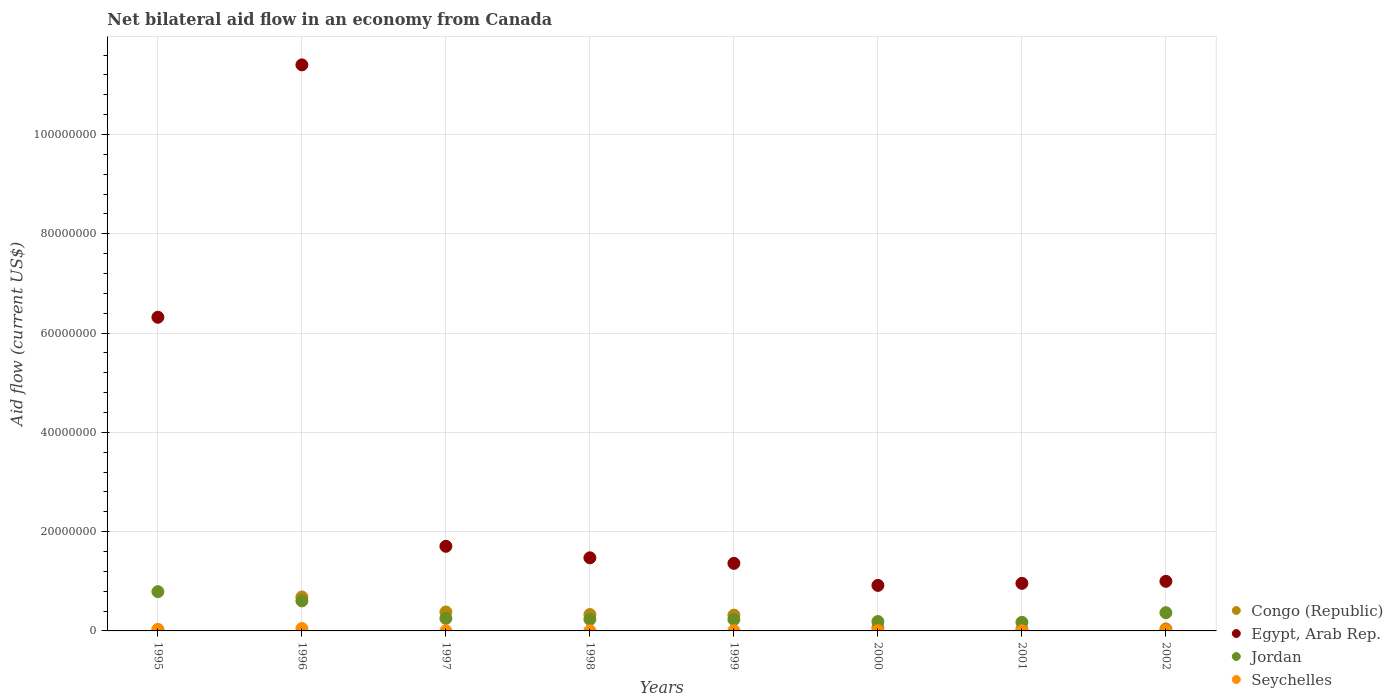How many different coloured dotlines are there?
Your answer should be compact. 4. What is the net bilateral aid flow in Jordan in 1996?
Offer a terse response. 6.05e+06. Across all years, what is the minimum net bilateral aid flow in Jordan?
Your response must be concise. 1.73e+06. In which year was the net bilateral aid flow in Egypt, Arab Rep. minimum?
Provide a short and direct response. 2000. What is the total net bilateral aid flow in Congo (Republic) in the graph?
Your answer should be very brief. 1.88e+07. What is the difference between the net bilateral aid flow in Jordan in 1995 and that in 1996?
Your answer should be very brief. 1.86e+06. What is the difference between the net bilateral aid flow in Jordan in 1995 and the net bilateral aid flow in Congo (Republic) in 2001?
Your answer should be compact. 7.57e+06. What is the average net bilateral aid flow in Congo (Republic) per year?
Your answer should be compact. 2.34e+06. In the year 1996, what is the difference between the net bilateral aid flow in Congo (Republic) and net bilateral aid flow in Egypt, Arab Rep.?
Ensure brevity in your answer.  -1.07e+08. What is the ratio of the net bilateral aid flow in Jordan in 1998 to that in 2002?
Your answer should be very brief. 0.63. Is the net bilateral aid flow in Egypt, Arab Rep. in 1997 less than that in 1998?
Give a very brief answer. No. Is the difference between the net bilateral aid flow in Congo (Republic) in 1996 and 2000 greater than the difference between the net bilateral aid flow in Egypt, Arab Rep. in 1996 and 2000?
Offer a very short reply. No. What is the difference between the highest and the second highest net bilateral aid flow in Jordan?
Your response must be concise. 1.86e+06. What is the difference between the highest and the lowest net bilateral aid flow in Jordan?
Ensure brevity in your answer.  6.18e+06. In how many years, is the net bilateral aid flow in Seychelles greater than the average net bilateral aid flow in Seychelles taken over all years?
Offer a very short reply. 2. Is the sum of the net bilateral aid flow in Congo (Republic) in 1999 and 2002 greater than the maximum net bilateral aid flow in Egypt, Arab Rep. across all years?
Provide a succinct answer. No. Is it the case that in every year, the sum of the net bilateral aid flow in Egypt, Arab Rep. and net bilateral aid flow in Congo (Republic)  is greater than the sum of net bilateral aid flow in Jordan and net bilateral aid flow in Seychelles?
Ensure brevity in your answer.  No. Is it the case that in every year, the sum of the net bilateral aid flow in Egypt, Arab Rep. and net bilateral aid flow in Jordan  is greater than the net bilateral aid flow in Seychelles?
Keep it short and to the point. Yes. Is the net bilateral aid flow in Seychelles strictly greater than the net bilateral aid flow in Congo (Republic) over the years?
Your answer should be very brief. No. How many dotlines are there?
Give a very brief answer. 4. How many years are there in the graph?
Ensure brevity in your answer.  8. What is the difference between two consecutive major ticks on the Y-axis?
Ensure brevity in your answer.  2.00e+07. Does the graph contain any zero values?
Offer a very short reply. No. What is the title of the graph?
Your response must be concise. Net bilateral aid flow in an economy from Canada. Does "Ghana" appear as one of the legend labels in the graph?
Ensure brevity in your answer.  No. What is the label or title of the X-axis?
Make the answer very short. Years. What is the Aid flow (current US$) of Egypt, Arab Rep. in 1995?
Your response must be concise. 6.32e+07. What is the Aid flow (current US$) in Jordan in 1995?
Provide a succinct answer. 7.91e+06. What is the Aid flow (current US$) in Congo (Republic) in 1996?
Your response must be concise. 6.84e+06. What is the Aid flow (current US$) of Egypt, Arab Rep. in 1996?
Make the answer very short. 1.14e+08. What is the Aid flow (current US$) of Jordan in 1996?
Your answer should be very brief. 6.05e+06. What is the Aid flow (current US$) in Congo (Republic) in 1997?
Provide a succinct answer. 3.82e+06. What is the Aid flow (current US$) of Egypt, Arab Rep. in 1997?
Provide a short and direct response. 1.70e+07. What is the Aid flow (current US$) of Jordan in 1997?
Give a very brief answer. 2.52e+06. What is the Aid flow (current US$) in Seychelles in 1997?
Your response must be concise. 2.00e+04. What is the Aid flow (current US$) in Congo (Republic) in 1998?
Offer a very short reply. 3.30e+06. What is the Aid flow (current US$) of Egypt, Arab Rep. in 1998?
Offer a very short reply. 1.47e+07. What is the Aid flow (current US$) of Jordan in 1998?
Offer a very short reply. 2.33e+06. What is the Aid flow (current US$) of Seychelles in 1998?
Your answer should be compact. 3.00e+04. What is the Aid flow (current US$) in Congo (Republic) in 1999?
Provide a succinct answer. 3.18e+06. What is the Aid flow (current US$) of Egypt, Arab Rep. in 1999?
Provide a short and direct response. 1.36e+07. What is the Aid flow (current US$) in Jordan in 1999?
Your answer should be very brief. 2.31e+06. What is the Aid flow (current US$) in Congo (Republic) in 2000?
Make the answer very short. 6.70e+05. What is the Aid flow (current US$) in Egypt, Arab Rep. in 2000?
Give a very brief answer. 9.17e+06. What is the Aid flow (current US$) of Jordan in 2000?
Provide a short and direct response. 1.89e+06. What is the Aid flow (current US$) in Seychelles in 2000?
Offer a terse response. 5.00e+04. What is the Aid flow (current US$) of Congo (Republic) in 2001?
Offer a terse response. 3.40e+05. What is the Aid flow (current US$) of Egypt, Arab Rep. in 2001?
Provide a succinct answer. 9.58e+06. What is the Aid flow (current US$) of Jordan in 2001?
Your response must be concise. 1.73e+06. What is the Aid flow (current US$) in Seychelles in 2001?
Your answer should be compact. 2.00e+04. What is the Aid flow (current US$) of Congo (Republic) in 2002?
Provide a short and direct response. 4.00e+05. What is the Aid flow (current US$) of Egypt, Arab Rep. in 2002?
Offer a terse response. 9.99e+06. What is the Aid flow (current US$) in Jordan in 2002?
Your answer should be very brief. 3.67e+06. Across all years, what is the maximum Aid flow (current US$) in Congo (Republic)?
Ensure brevity in your answer.  6.84e+06. Across all years, what is the maximum Aid flow (current US$) of Egypt, Arab Rep.?
Your response must be concise. 1.14e+08. Across all years, what is the maximum Aid flow (current US$) in Jordan?
Provide a succinct answer. 7.91e+06. Across all years, what is the maximum Aid flow (current US$) in Seychelles?
Keep it short and to the point. 4.80e+05. Across all years, what is the minimum Aid flow (current US$) of Egypt, Arab Rep.?
Offer a terse response. 9.17e+06. Across all years, what is the minimum Aid flow (current US$) in Jordan?
Provide a succinct answer. 1.73e+06. Across all years, what is the minimum Aid flow (current US$) in Seychelles?
Provide a succinct answer. 2.00e+04. What is the total Aid flow (current US$) in Congo (Republic) in the graph?
Provide a short and direct response. 1.88e+07. What is the total Aid flow (current US$) of Egypt, Arab Rep. in the graph?
Your answer should be compact. 2.51e+08. What is the total Aid flow (current US$) in Jordan in the graph?
Make the answer very short. 2.84e+07. What is the total Aid flow (current US$) in Seychelles in the graph?
Provide a succinct answer. 1.02e+06. What is the difference between the Aid flow (current US$) in Congo (Republic) in 1995 and that in 1996?
Make the answer very short. -6.63e+06. What is the difference between the Aid flow (current US$) of Egypt, Arab Rep. in 1995 and that in 1996?
Ensure brevity in your answer.  -5.08e+07. What is the difference between the Aid flow (current US$) in Jordan in 1995 and that in 1996?
Your response must be concise. 1.86e+06. What is the difference between the Aid flow (current US$) in Congo (Republic) in 1995 and that in 1997?
Ensure brevity in your answer.  -3.61e+06. What is the difference between the Aid flow (current US$) in Egypt, Arab Rep. in 1995 and that in 1997?
Offer a very short reply. 4.61e+07. What is the difference between the Aid flow (current US$) in Jordan in 1995 and that in 1997?
Your answer should be very brief. 5.39e+06. What is the difference between the Aid flow (current US$) of Congo (Republic) in 1995 and that in 1998?
Your answer should be very brief. -3.09e+06. What is the difference between the Aid flow (current US$) in Egypt, Arab Rep. in 1995 and that in 1998?
Keep it short and to the point. 4.85e+07. What is the difference between the Aid flow (current US$) in Jordan in 1995 and that in 1998?
Keep it short and to the point. 5.58e+06. What is the difference between the Aid flow (current US$) of Congo (Republic) in 1995 and that in 1999?
Provide a succinct answer. -2.97e+06. What is the difference between the Aid flow (current US$) in Egypt, Arab Rep. in 1995 and that in 1999?
Ensure brevity in your answer.  4.96e+07. What is the difference between the Aid flow (current US$) of Jordan in 1995 and that in 1999?
Offer a terse response. 5.60e+06. What is the difference between the Aid flow (current US$) in Congo (Republic) in 1995 and that in 2000?
Your response must be concise. -4.60e+05. What is the difference between the Aid flow (current US$) of Egypt, Arab Rep. in 1995 and that in 2000?
Your answer should be very brief. 5.40e+07. What is the difference between the Aid flow (current US$) of Jordan in 1995 and that in 2000?
Your answer should be compact. 6.02e+06. What is the difference between the Aid flow (current US$) of Egypt, Arab Rep. in 1995 and that in 2001?
Keep it short and to the point. 5.36e+07. What is the difference between the Aid flow (current US$) in Jordan in 1995 and that in 2001?
Your answer should be compact. 6.18e+06. What is the difference between the Aid flow (current US$) of Seychelles in 1995 and that in 2001?
Offer a very short reply. 2.80e+05. What is the difference between the Aid flow (current US$) in Congo (Republic) in 1995 and that in 2002?
Offer a very short reply. -1.90e+05. What is the difference between the Aid flow (current US$) in Egypt, Arab Rep. in 1995 and that in 2002?
Keep it short and to the point. 5.32e+07. What is the difference between the Aid flow (current US$) in Jordan in 1995 and that in 2002?
Give a very brief answer. 4.24e+06. What is the difference between the Aid flow (current US$) in Congo (Republic) in 1996 and that in 1997?
Ensure brevity in your answer.  3.02e+06. What is the difference between the Aid flow (current US$) in Egypt, Arab Rep. in 1996 and that in 1997?
Your answer should be very brief. 9.70e+07. What is the difference between the Aid flow (current US$) of Jordan in 1996 and that in 1997?
Your response must be concise. 3.53e+06. What is the difference between the Aid flow (current US$) of Congo (Republic) in 1996 and that in 1998?
Offer a very short reply. 3.54e+06. What is the difference between the Aid flow (current US$) in Egypt, Arab Rep. in 1996 and that in 1998?
Keep it short and to the point. 9.93e+07. What is the difference between the Aid flow (current US$) of Jordan in 1996 and that in 1998?
Make the answer very short. 3.72e+06. What is the difference between the Aid flow (current US$) of Seychelles in 1996 and that in 1998?
Make the answer very short. 4.50e+05. What is the difference between the Aid flow (current US$) in Congo (Republic) in 1996 and that in 1999?
Provide a succinct answer. 3.66e+06. What is the difference between the Aid flow (current US$) in Egypt, Arab Rep. in 1996 and that in 1999?
Provide a short and direct response. 1.00e+08. What is the difference between the Aid flow (current US$) of Jordan in 1996 and that in 1999?
Give a very brief answer. 3.74e+06. What is the difference between the Aid flow (current US$) in Congo (Republic) in 1996 and that in 2000?
Offer a very short reply. 6.17e+06. What is the difference between the Aid flow (current US$) in Egypt, Arab Rep. in 1996 and that in 2000?
Provide a short and direct response. 1.05e+08. What is the difference between the Aid flow (current US$) of Jordan in 1996 and that in 2000?
Ensure brevity in your answer.  4.16e+06. What is the difference between the Aid flow (current US$) of Congo (Republic) in 1996 and that in 2001?
Your response must be concise. 6.50e+06. What is the difference between the Aid flow (current US$) of Egypt, Arab Rep. in 1996 and that in 2001?
Your answer should be compact. 1.04e+08. What is the difference between the Aid flow (current US$) in Jordan in 1996 and that in 2001?
Offer a very short reply. 4.32e+06. What is the difference between the Aid flow (current US$) in Seychelles in 1996 and that in 2001?
Provide a succinct answer. 4.60e+05. What is the difference between the Aid flow (current US$) of Congo (Republic) in 1996 and that in 2002?
Keep it short and to the point. 6.44e+06. What is the difference between the Aid flow (current US$) of Egypt, Arab Rep. in 1996 and that in 2002?
Make the answer very short. 1.04e+08. What is the difference between the Aid flow (current US$) in Jordan in 1996 and that in 2002?
Offer a very short reply. 2.38e+06. What is the difference between the Aid flow (current US$) of Seychelles in 1996 and that in 2002?
Your response must be concise. 4.10e+05. What is the difference between the Aid flow (current US$) of Congo (Republic) in 1997 and that in 1998?
Your answer should be very brief. 5.20e+05. What is the difference between the Aid flow (current US$) of Egypt, Arab Rep. in 1997 and that in 1998?
Make the answer very short. 2.32e+06. What is the difference between the Aid flow (current US$) in Seychelles in 1997 and that in 1998?
Ensure brevity in your answer.  -10000. What is the difference between the Aid flow (current US$) in Congo (Republic) in 1997 and that in 1999?
Offer a terse response. 6.40e+05. What is the difference between the Aid flow (current US$) in Egypt, Arab Rep. in 1997 and that in 1999?
Your response must be concise. 3.44e+06. What is the difference between the Aid flow (current US$) in Seychelles in 1997 and that in 1999?
Make the answer very short. -3.00e+04. What is the difference between the Aid flow (current US$) of Congo (Republic) in 1997 and that in 2000?
Ensure brevity in your answer.  3.15e+06. What is the difference between the Aid flow (current US$) of Egypt, Arab Rep. in 1997 and that in 2000?
Offer a very short reply. 7.88e+06. What is the difference between the Aid flow (current US$) in Jordan in 1997 and that in 2000?
Offer a terse response. 6.30e+05. What is the difference between the Aid flow (current US$) in Seychelles in 1997 and that in 2000?
Offer a very short reply. -3.00e+04. What is the difference between the Aid flow (current US$) of Congo (Republic) in 1997 and that in 2001?
Provide a succinct answer. 3.48e+06. What is the difference between the Aid flow (current US$) in Egypt, Arab Rep. in 1997 and that in 2001?
Offer a terse response. 7.47e+06. What is the difference between the Aid flow (current US$) in Jordan in 1997 and that in 2001?
Make the answer very short. 7.90e+05. What is the difference between the Aid flow (current US$) in Seychelles in 1997 and that in 2001?
Your answer should be very brief. 0. What is the difference between the Aid flow (current US$) of Congo (Republic) in 1997 and that in 2002?
Your answer should be compact. 3.42e+06. What is the difference between the Aid flow (current US$) of Egypt, Arab Rep. in 1997 and that in 2002?
Your response must be concise. 7.06e+06. What is the difference between the Aid flow (current US$) in Jordan in 1997 and that in 2002?
Offer a terse response. -1.15e+06. What is the difference between the Aid flow (current US$) in Seychelles in 1997 and that in 2002?
Ensure brevity in your answer.  -5.00e+04. What is the difference between the Aid flow (current US$) in Egypt, Arab Rep. in 1998 and that in 1999?
Give a very brief answer. 1.12e+06. What is the difference between the Aid flow (current US$) in Seychelles in 1998 and that in 1999?
Offer a very short reply. -2.00e+04. What is the difference between the Aid flow (current US$) of Congo (Republic) in 1998 and that in 2000?
Your answer should be very brief. 2.63e+06. What is the difference between the Aid flow (current US$) in Egypt, Arab Rep. in 1998 and that in 2000?
Your answer should be compact. 5.56e+06. What is the difference between the Aid flow (current US$) in Jordan in 1998 and that in 2000?
Your answer should be compact. 4.40e+05. What is the difference between the Aid flow (current US$) in Seychelles in 1998 and that in 2000?
Keep it short and to the point. -2.00e+04. What is the difference between the Aid flow (current US$) in Congo (Republic) in 1998 and that in 2001?
Give a very brief answer. 2.96e+06. What is the difference between the Aid flow (current US$) of Egypt, Arab Rep. in 1998 and that in 2001?
Offer a terse response. 5.15e+06. What is the difference between the Aid flow (current US$) in Jordan in 1998 and that in 2001?
Your answer should be compact. 6.00e+05. What is the difference between the Aid flow (current US$) of Congo (Republic) in 1998 and that in 2002?
Give a very brief answer. 2.90e+06. What is the difference between the Aid flow (current US$) of Egypt, Arab Rep. in 1998 and that in 2002?
Keep it short and to the point. 4.74e+06. What is the difference between the Aid flow (current US$) of Jordan in 1998 and that in 2002?
Ensure brevity in your answer.  -1.34e+06. What is the difference between the Aid flow (current US$) in Congo (Republic) in 1999 and that in 2000?
Offer a very short reply. 2.51e+06. What is the difference between the Aid flow (current US$) in Egypt, Arab Rep. in 1999 and that in 2000?
Provide a short and direct response. 4.44e+06. What is the difference between the Aid flow (current US$) of Jordan in 1999 and that in 2000?
Your answer should be very brief. 4.20e+05. What is the difference between the Aid flow (current US$) in Congo (Republic) in 1999 and that in 2001?
Make the answer very short. 2.84e+06. What is the difference between the Aid flow (current US$) of Egypt, Arab Rep. in 1999 and that in 2001?
Your answer should be compact. 4.03e+06. What is the difference between the Aid flow (current US$) of Jordan in 1999 and that in 2001?
Offer a very short reply. 5.80e+05. What is the difference between the Aid flow (current US$) of Congo (Republic) in 1999 and that in 2002?
Offer a terse response. 2.78e+06. What is the difference between the Aid flow (current US$) in Egypt, Arab Rep. in 1999 and that in 2002?
Ensure brevity in your answer.  3.62e+06. What is the difference between the Aid flow (current US$) of Jordan in 1999 and that in 2002?
Keep it short and to the point. -1.36e+06. What is the difference between the Aid flow (current US$) of Egypt, Arab Rep. in 2000 and that in 2001?
Ensure brevity in your answer.  -4.10e+05. What is the difference between the Aid flow (current US$) of Jordan in 2000 and that in 2001?
Offer a very short reply. 1.60e+05. What is the difference between the Aid flow (current US$) of Congo (Republic) in 2000 and that in 2002?
Your response must be concise. 2.70e+05. What is the difference between the Aid flow (current US$) in Egypt, Arab Rep. in 2000 and that in 2002?
Give a very brief answer. -8.20e+05. What is the difference between the Aid flow (current US$) in Jordan in 2000 and that in 2002?
Ensure brevity in your answer.  -1.78e+06. What is the difference between the Aid flow (current US$) of Seychelles in 2000 and that in 2002?
Offer a very short reply. -2.00e+04. What is the difference between the Aid flow (current US$) of Congo (Republic) in 2001 and that in 2002?
Give a very brief answer. -6.00e+04. What is the difference between the Aid flow (current US$) in Egypt, Arab Rep. in 2001 and that in 2002?
Your answer should be very brief. -4.10e+05. What is the difference between the Aid flow (current US$) of Jordan in 2001 and that in 2002?
Keep it short and to the point. -1.94e+06. What is the difference between the Aid flow (current US$) in Seychelles in 2001 and that in 2002?
Give a very brief answer. -5.00e+04. What is the difference between the Aid flow (current US$) in Congo (Republic) in 1995 and the Aid flow (current US$) in Egypt, Arab Rep. in 1996?
Provide a succinct answer. -1.14e+08. What is the difference between the Aid flow (current US$) of Congo (Republic) in 1995 and the Aid flow (current US$) of Jordan in 1996?
Your response must be concise. -5.84e+06. What is the difference between the Aid flow (current US$) in Congo (Republic) in 1995 and the Aid flow (current US$) in Seychelles in 1996?
Provide a succinct answer. -2.70e+05. What is the difference between the Aid flow (current US$) of Egypt, Arab Rep. in 1995 and the Aid flow (current US$) of Jordan in 1996?
Keep it short and to the point. 5.71e+07. What is the difference between the Aid flow (current US$) of Egypt, Arab Rep. in 1995 and the Aid flow (current US$) of Seychelles in 1996?
Provide a succinct answer. 6.27e+07. What is the difference between the Aid flow (current US$) of Jordan in 1995 and the Aid flow (current US$) of Seychelles in 1996?
Your answer should be compact. 7.43e+06. What is the difference between the Aid flow (current US$) of Congo (Republic) in 1995 and the Aid flow (current US$) of Egypt, Arab Rep. in 1997?
Give a very brief answer. -1.68e+07. What is the difference between the Aid flow (current US$) of Congo (Republic) in 1995 and the Aid flow (current US$) of Jordan in 1997?
Offer a terse response. -2.31e+06. What is the difference between the Aid flow (current US$) of Egypt, Arab Rep. in 1995 and the Aid flow (current US$) of Jordan in 1997?
Give a very brief answer. 6.07e+07. What is the difference between the Aid flow (current US$) of Egypt, Arab Rep. in 1995 and the Aid flow (current US$) of Seychelles in 1997?
Your response must be concise. 6.32e+07. What is the difference between the Aid flow (current US$) of Jordan in 1995 and the Aid flow (current US$) of Seychelles in 1997?
Provide a succinct answer. 7.89e+06. What is the difference between the Aid flow (current US$) of Congo (Republic) in 1995 and the Aid flow (current US$) of Egypt, Arab Rep. in 1998?
Offer a terse response. -1.45e+07. What is the difference between the Aid flow (current US$) in Congo (Republic) in 1995 and the Aid flow (current US$) in Jordan in 1998?
Ensure brevity in your answer.  -2.12e+06. What is the difference between the Aid flow (current US$) of Congo (Republic) in 1995 and the Aid flow (current US$) of Seychelles in 1998?
Make the answer very short. 1.80e+05. What is the difference between the Aid flow (current US$) in Egypt, Arab Rep. in 1995 and the Aid flow (current US$) in Jordan in 1998?
Offer a terse response. 6.09e+07. What is the difference between the Aid flow (current US$) in Egypt, Arab Rep. in 1995 and the Aid flow (current US$) in Seychelles in 1998?
Provide a succinct answer. 6.32e+07. What is the difference between the Aid flow (current US$) in Jordan in 1995 and the Aid flow (current US$) in Seychelles in 1998?
Ensure brevity in your answer.  7.88e+06. What is the difference between the Aid flow (current US$) in Congo (Republic) in 1995 and the Aid flow (current US$) in Egypt, Arab Rep. in 1999?
Provide a short and direct response. -1.34e+07. What is the difference between the Aid flow (current US$) in Congo (Republic) in 1995 and the Aid flow (current US$) in Jordan in 1999?
Provide a succinct answer. -2.10e+06. What is the difference between the Aid flow (current US$) in Egypt, Arab Rep. in 1995 and the Aid flow (current US$) in Jordan in 1999?
Give a very brief answer. 6.09e+07. What is the difference between the Aid flow (current US$) of Egypt, Arab Rep. in 1995 and the Aid flow (current US$) of Seychelles in 1999?
Ensure brevity in your answer.  6.31e+07. What is the difference between the Aid flow (current US$) of Jordan in 1995 and the Aid flow (current US$) of Seychelles in 1999?
Provide a succinct answer. 7.86e+06. What is the difference between the Aid flow (current US$) in Congo (Republic) in 1995 and the Aid flow (current US$) in Egypt, Arab Rep. in 2000?
Provide a short and direct response. -8.96e+06. What is the difference between the Aid flow (current US$) in Congo (Republic) in 1995 and the Aid flow (current US$) in Jordan in 2000?
Offer a terse response. -1.68e+06. What is the difference between the Aid flow (current US$) of Egypt, Arab Rep. in 1995 and the Aid flow (current US$) of Jordan in 2000?
Provide a succinct answer. 6.13e+07. What is the difference between the Aid flow (current US$) of Egypt, Arab Rep. in 1995 and the Aid flow (current US$) of Seychelles in 2000?
Your response must be concise. 6.31e+07. What is the difference between the Aid flow (current US$) of Jordan in 1995 and the Aid flow (current US$) of Seychelles in 2000?
Offer a very short reply. 7.86e+06. What is the difference between the Aid flow (current US$) in Congo (Republic) in 1995 and the Aid flow (current US$) in Egypt, Arab Rep. in 2001?
Your answer should be very brief. -9.37e+06. What is the difference between the Aid flow (current US$) in Congo (Republic) in 1995 and the Aid flow (current US$) in Jordan in 2001?
Offer a terse response. -1.52e+06. What is the difference between the Aid flow (current US$) in Egypt, Arab Rep. in 1995 and the Aid flow (current US$) in Jordan in 2001?
Provide a succinct answer. 6.15e+07. What is the difference between the Aid flow (current US$) in Egypt, Arab Rep. in 1995 and the Aid flow (current US$) in Seychelles in 2001?
Your answer should be compact. 6.32e+07. What is the difference between the Aid flow (current US$) of Jordan in 1995 and the Aid flow (current US$) of Seychelles in 2001?
Offer a very short reply. 7.89e+06. What is the difference between the Aid flow (current US$) of Congo (Republic) in 1995 and the Aid flow (current US$) of Egypt, Arab Rep. in 2002?
Your answer should be very brief. -9.78e+06. What is the difference between the Aid flow (current US$) of Congo (Republic) in 1995 and the Aid flow (current US$) of Jordan in 2002?
Provide a succinct answer. -3.46e+06. What is the difference between the Aid flow (current US$) of Egypt, Arab Rep. in 1995 and the Aid flow (current US$) of Jordan in 2002?
Ensure brevity in your answer.  5.95e+07. What is the difference between the Aid flow (current US$) in Egypt, Arab Rep. in 1995 and the Aid flow (current US$) in Seychelles in 2002?
Offer a very short reply. 6.31e+07. What is the difference between the Aid flow (current US$) of Jordan in 1995 and the Aid flow (current US$) of Seychelles in 2002?
Give a very brief answer. 7.84e+06. What is the difference between the Aid flow (current US$) in Congo (Republic) in 1996 and the Aid flow (current US$) in Egypt, Arab Rep. in 1997?
Provide a short and direct response. -1.02e+07. What is the difference between the Aid flow (current US$) in Congo (Republic) in 1996 and the Aid flow (current US$) in Jordan in 1997?
Provide a short and direct response. 4.32e+06. What is the difference between the Aid flow (current US$) in Congo (Republic) in 1996 and the Aid flow (current US$) in Seychelles in 1997?
Keep it short and to the point. 6.82e+06. What is the difference between the Aid flow (current US$) in Egypt, Arab Rep. in 1996 and the Aid flow (current US$) in Jordan in 1997?
Give a very brief answer. 1.12e+08. What is the difference between the Aid flow (current US$) of Egypt, Arab Rep. in 1996 and the Aid flow (current US$) of Seychelles in 1997?
Ensure brevity in your answer.  1.14e+08. What is the difference between the Aid flow (current US$) in Jordan in 1996 and the Aid flow (current US$) in Seychelles in 1997?
Give a very brief answer. 6.03e+06. What is the difference between the Aid flow (current US$) of Congo (Republic) in 1996 and the Aid flow (current US$) of Egypt, Arab Rep. in 1998?
Your response must be concise. -7.89e+06. What is the difference between the Aid flow (current US$) in Congo (Republic) in 1996 and the Aid flow (current US$) in Jordan in 1998?
Offer a terse response. 4.51e+06. What is the difference between the Aid flow (current US$) in Congo (Republic) in 1996 and the Aid flow (current US$) in Seychelles in 1998?
Your answer should be very brief. 6.81e+06. What is the difference between the Aid flow (current US$) of Egypt, Arab Rep. in 1996 and the Aid flow (current US$) of Jordan in 1998?
Your answer should be compact. 1.12e+08. What is the difference between the Aid flow (current US$) in Egypt, Arab Rep. in 1996 and the Aid flow (current US$) in Seychelles in 1998?
Offer a terse response. 1.14e+08. What is the difference between the Aid flow (current US$) of Jordan in 1996 and the Aid flow (current US$) of Seychelles in 1998?
Your answer should be very brief. 6.02e+06. What is the difference between the Aid flow (current US$) in Congo (Republic) in 1996 and the Aid flow (current US$) in Egypt, Arab Rep. in 1999?
Make the answer very short. -6.77e+06. What is the difference between the Aid flow (current US$) of Congo (Republic) in 1996 and the Aid flow (current US$) of Jordan in 1999?
Keep it short and to the point. 4.53e+06. What is the difference between the Aid flow (current US$) in Congo (Republic) in 1996 and the Aid flow (current US$) in Seychelles in 1999?
Ensure brevity in your answer.  6.79e+06. What is the difference between the Aid flow (current US$) in Egypt, Arab Rep. in 1996 and the Aid flow (current US$) in Jordan in 1999?
Make the answer very short. 1.12e+08. What is the difference between the Aid flow (current US$) of Egypt, Arab Rep. in 1996 and the Aid flow (current US$) of Seychelles in 1999?
Your answer should be compact. 1.14e+08. What is the difference between the Aid flow (current US$) of Congo (Republic) in 1996 and the Aid flow (current US$) of Egypt, Arab Rep. in 2000?
Ensure brevity in your answer.  -2.33e+06. What is the difference between the Aid flow (current US$) of Congo (Republic) in 1996 and the Aid flow (current US$) of Jordan in 2000?
Your answer should be very brief. 4.95e+06. What is the difference between the Aid flow (current US$) of Congo (Republic) in 1996 and the Aid flow (current US$) of Seychelles in 2000?
Your answer should be very brief. 6.79e+06. What is the difference between the Aid flow (current US$) of Egypt, Arab Rep. in 1996 and the Aid flow (current US$) of Jordan in 2000?
Your answer should be very brief. 1.12e+08. What is the difference between the Aid flow (current US$) of Egypt, Arab Rep. in 1996 and the Aid flow (current US$) of Seychelles in 2000?
Provide a succinct answer. 1.14e+08. What is the difference between the Aid flow (current US$) in Congo (Republic) in 1996 and the Aid flow (current US$) in Egypt, Arab Rep. in 2001?
Keep it short and to the point. -2.74e+06. What is the difference between the Aid flow (current US$) of Congo (Republic) in 1996 and the Aid flow (current US$) of Jordan in 2001?
Offer a very short reply. 5.11e+06. What is the difference between the Aid flow (current US$) in Congo (Republic) in 1996 and the Aid flow (current US$) in Seychelles in 2001?
Make the answer very short. 6.82e+06. What is the difference between the Aid flow (current US$) in Egypt, Arab Rep. in 1996 and the Aid flow (current US$) in Jordan in 2001?
Your answer should be compact. 1.12e+08. What is the difference between the Aid flow (current US$) of Egypt, Arab Rep. in 1996 and the Aid flow (current US$) of Seychelles in 2001?
Provide a succinct answer. 1.14e+08. What is the difference between the Aid flow (current US$) in Jordan in 1996 and the Aid flow (current US$) in Seychelles in 2001?
Give a very brief answer. 6.03e+06. What is the difference between the Aid flow (current US$) of Congo (Republic) in 1996 and the Aid flow (current US$) of Egypt, Arab Rep. in 2002?
Give a very brief answer. -3.15e+06. What is the difference between the Aid flow (current US$) in Congo (Republic) in 1996 and the Aid flow (current US$) in Jordan in 2002?
Your answer should be very brief. 3.17e+06. What is the difference between the Aid flow (current US$) in Congo (Republic) in 1996 and the Aid flow (current US$) in Seychelles in 2002?
Your answer should be very brief. 6.77e+06. What is the difference between the Aid flow (current US$) of Egypt, Arab Rep. in 1996 and the Aid flow (current US$) of Jordan in 2002?
Provide a succinct answer. 1.10e+08. What is the difference between the Aid flow (current US$) in Egypt, Arab Rep. in 1996 and the Aid flow (current US$) in Seychelles in 2002?
Ensure brevity in your answer.  1.14e+08. What is the difference between the Aid flow (current US$) of Jordan in 1996 and the Aid flow (current US$) of Seychelles in 2002?
Provide a succinct answer. 5.98e+06. What is the difference between the Aid flow (current US$) of Congo (Republic) in 1997 and the Aid flow (current US$) of Egypt, Arab Rep. in 1998?
Provide a succinct answer. -1.09e+07. What is the difference between the Aid flow (current US$) in Congo (Republic) in 1997 and the Aid flow (current US$) in Jordan in 1998?
Your answer should be very brief. 1.49e+06. What is the difference between the Aid flow (current US$) of Congo (Republic) in 1997 and the Aid flow (current US$) of Seychelles in 1998?
Your answer should be compact. 3.79e+06. What is the difference between the Aid flow (current US$) of Egypt, Arab Rep. in 1997 and the Aid flow (current US$) of Jordan in 1998?
Provide a short and direct response. 1.47e+07. What is the difference between the Aid flow (current US$) of Egypt, Arab Rep. in 1997 and the Aid flow (current US$) of Seychelles in 1998?
Your answer should be very brief. 1.70e+07. What is the difference between the Aid flow (current US$) of Jordan in 1997 and the Aid flow (current US$) of Seychelles in 1998?
Make the answer very short. 2.49e+06. What is the difference between the Aid flow (current US$) of Congo (Republic) in 1997 and the Aid flow (current US$) of Egypt, Arab Rep. in 1999?
Ensure brevity in your answer.  -9.79e+06. What is the difference between the Aid flow (current US$) in Congo (Republic) in 1997 and the Aid flow (current US$) in Jordan in 1999?
Your answer should be very brief. 1.51e+06. What is the difference between the Aid flow (current US$) in Congo (Republic) in 1997 and the Aid flow (current US$) in Seychelles in 1999?
Provide a succinct answer. 3.77e+06. What is the difference between the Aid flow (current US$) in Egypt, Arab Rep. in 1997 and the Aid flow (current US$) in Jordan in 1999?
Make the answer very short. 1.47e+07. What is the difference between the Aid flow (current US$) in Egypt, Arab Rep. in 1997 and the Aid flow (current US$) in Seychelles in 1999?
Ensure brevity in your answer.  1.70e+07. What is the difference between the Aid flow (current US$) in Jordan in 1997 and the Aid flow (current US$) in Seychelles in 1999?
Make the answer very short. 2.47e+06. What is the difference between the Aid flow (current US$) in Congo (Republic) in 1997 and the Aid flow (current US$) in Egypt, Arab Rep. in 2000?
Offer a very short reply. -5.35e+06. What is the difference between the Aid flow (current US$) of Congo (Republic) in 1997 and the Aid flow (current US$) of Jordan in 2000?
Ensure brevity in your answer.  1.93e+06. What is the difference between the Aid flow (current US$) in Congo (Republic) in 1997 and the Aid flow (current US$) in Seychelles in 2000?
Keep it short and to the point. 3.77e+06. What is the difference between the Aid flow (current US$) in Egypt, Arab Rep. in 1997 and the Aid flow (current US$) in Jordan in 2000?
Offer a terse response. 1.52e+07. What is the difference between the Aid flow (current US$) in Egypt, Arab Rep. in 1997 and the Aid flow (current US$) in Seychelles in 2000?
Keep it short and to the point. 1.70e+07. What is the difference between the Aid flow (current US$) in Jordan in 1997 and the Aid flow (current US$) in Seychelles in 2000?
Ensure brevity in your answer.  2.47e+06. What is the difference between the Aid flow (current US$) in Congo (Republic) in 1997 and the Aid flow (current US$) in Egypt, Arab Rep. in 2001?
Keep it short and to the point. -5.76e+06. What is the difference between the Aid flow (current US$) in Congo (Republic) in 1997 and the Aid flow (current US$) in Jordan in 2001?
Your response must be concise. 2.09e+06. What is the difference between the Aid flow (current US$) in Congo (Republic) in 1997 and the Aid flow (current US$) in Seychelles in 2001?
Make the answer very short. 3.80e+06. What is the difference between the Aid flow (current US$) in Egypt, Arab Rep. in 1997 and the Aid flow (current US$) in Jordan in 2001?
Your response must be concise. 1.53e+07. What is the difference between the Aid flow (current US$) in Egypt, Arab Rep. in 1997 and the Aid flow (current US$) in Seychelles in 2001?
Offer a very short reply. 1.70e+07. What is the difference between the Aid flow (current US$) of Jordan in 1997 and the Aid flow (current US$) of Seychelles in 2001?
Provide a succinct answer. 2.50e+06. What is the difference between the Aid flow (current US$) in Congo (Republic) in 1997 and the Aid flow (current US$) in Egypt, Arab Rep. in 2002?
Make the answer very short. -6.17e+06. What is the difference between the Aid flow (current US$) of Congo (Republic) in 1997 and the Aid flow (current US$) of Jordan in 2002?
Offer a terse response. 1.50e+05. What is the difference between the Aid flow (current US$) in Congo (Republic) in 1997 and the Aid flow (current US$) in Seychelles in 2002?
Your answer should be very brief. 3.75e+06. What is the difference between the Aid flow (current US$) of Egypt, Arab Rep. in 1997 and the Aid flow (current US$) of Jordan in 2002?
Offer a terse response. 1.34e+07. What is the difference between the Aid flow (current US$) of Egypt, Arab Rep. in 1997 and the Aid flow (current US$) of Seychelles in 2002?
Your answer should be very brief. 1.70e+07. What is the difference between the Aid flow (current US$) in Jordan in 1997 and the Aid flow (current US$) in Seychelles in 2002?
Your response must be concise. 2.45e+06. What is the difference between the Aid flow (current US$) of Congo (Republic) in 1998 and the Aid flow (current US$) of Egypt, Arab Rep. in 1999?
Give a very brief answer. -1.03e+07. What is the difference between the Aid flow (current US$) of Congo (Republic) in 1998 and the Aid flow (current US$) of Jordan in 1999?
Offer a terse response. 9.90e+05. What is the difference between the Aid flow (current US$) of Congo (Republic) in 1998 and the Aid flow (current US$) of Seychelles in 1999?
Keep it short and to the point. 3.25e+06. What is the difference between the Aid flow (current US$) in Egypt, Arab Rep. in 1998 and the Aid flow (current US$) in Jordan in 1999?
Offer a very short reply. 1.24e+07. What is the difference between the Aid flow (current US$) in Egypt, Arab Rep. in 1998 and the Aid flow (current US$) in Seychelles in 1999?
Ensure brevity in your answer.  1.47e+07. What is the difference between the Aid flow (current US$) of Jordan in 1998 and the Aid flow (current US$) of Seychelles in 1999?
Keep it short and to the point. 2.28e+06. What is the difference between the Aid flow (current US$) of Congo (Republic) in 1998 and the Aid flow (current US$) of Egypt, Arab Rep. in 2000?
Your response must be concise. -5.87e+06. What is the difference between the Aid flow (current US$) of Congo (Republic) in 1998 and the Aid flow (current US$) of Jordan in 2000?
Keep it short and to the point. 1.41e+06. What is the difference between the Aid flow (current US$) in Congo (Republic) in 1998 and the Aid flow (current US$) in Seychelles in 2000?
Your answer should be compact. 3.25e+06. What is the difference between the Aid flow (current US$) of Egypt, Arab Rep. in 1998 and the Aid flow (current US$) of Jordan in 2000?
Your answer should be compact. 1.28e+07. What is the difference between the Aid flow (current US$) of Egypt, Arab Rep. in 1998 and the Aid flow (current US$) of Seychelles in 2000?
Provide a short and direct response. 1.47e+07. What is the difference between the Aid flow (current US$) in Jordan in 1998 and the Aid flow (current US$) in Seychelles in 2000?
Offer a terse response. 2.28e+06. What is the difference between the Aid flow (current US$) of Congo (Republic) in 1998 and the Aid flow (current US$) of Egypt, Arab Rep. in 2001?
Your answer should be very brief. -6.28e+06. What is the difference between the Aid flow (current US$) of Congo (Republic) in 1998 and the Aid flow (current US$) of Jordan in 2001?
Your answer should be very brief. 1.57e+06. What is the difference between the Aid flow (current US$) in Congo (Republic) in 1998 and the Aid flow (current US$) in Seychelles in 2001?
Give a very brief answer. 3.28e+06. What is the difference between the Aid flow (current US$) in Egypt, Arab Rep. in 1998 and the Aid flow (current US$) in Jordan in 2001?
Offer a terse response. 1.30e+07. What is the difference between the Aid flow (current US$) of Egypt, Arab Rep. in 1998 and the Aid flow (current US$) of Seychelles in 2001?
Give a very brief answer. 1.47e+07. What is the difference between the Aid flow (current US$) in Jordan in 1998 and the Aid flow (current US$) in Seychelles in 2001?
Offer a terse response. 2.31e+06. What is the difference between the Aid flow (current US$) in Congo (Republic) in 1998 and the Aid flow (current US$) in Egypt, Arab Rep. in 2002?
Offer a terse response. -6.69e+06. What is the difference between the Aid flow (current US$) in Congo (Republic) in 1998 and the Aid flow (current US$) in Jordan in 2002?
Your answer should be very brief. -3.70e+05. What is the difference between the Aid flow (current US$) of Congo (Republic) in 1998 and the Aid flow (current US$) of Seychelles in 2002?
Provide a short and direct response. 3.23e+06. What is the difference between the Aid flow (current US$) in Egypt, Arab Rep. in 1998 and the Aid flow (current US$) in Jordan in 2002?
Your answer should be compact. 1.11e+07. What is the difference between the Aid flow (current US$) of Egypt, Arab Rep. in 1998 and the Aid flow (current US$) of Seychelles in 2002?
Provide a short and direct response. 1.47e+07. What is the difference between the Aid flow (current US$) in Jordan in 1998 and the Aid flow (current US$) in Seychelles in 2002?
Give a very brief answer. 2.26e+06. What is the difference between the Aid flow (current US$) of Congo (Republic) in 1999 and the Aid flow (current US$) of Egypt, Arab Rep. in 2000?
Provide a succinct answer. -5.99e+06. What is the difference between the Aid flow (current US$) of Congo (Republic) in 1999 and the Aid flow (current US$) of Jordan in 2000?
Your answer should be very brief. 1.29e+06. What is the difference between the Aid flow (current US$) of Congo (Republic) in 1999 and the Aid flow (current US$) of Seychelles in 2000?
Keep it short and to the point. 3.13e+06. What is the difference between the Aid flow (current US$) of Egypt, Arab Rep. in 1999 and the Aid flow (current US$) of Jordan in 2000?
Your response must be concise. 1.17e+07. What is the difference between the Aid flow (current US$) of Egypt, Arab Rep. in 1999 and the Aid flow (current US$) of Seychelles in 2000?
Make the answer very short. 1.36e+07. What is the difference between the Aid flow (current US$) in Jordan in 1999 and the Aid flow (current US$) in Seychelles in 2000?
Give a very brief answer. 2.26e+06. What is the difference between the Aid flow (current US$) of Congo (Republic) in 1999 and the Aid flow (current US$) of Egypt, Arab Rep. in 2001?
Give a very brief answer. -6.40e+06. What is the difference between the Aid flow (current US$) in Congo (Republic) in 1999 and the Aid flow (current US$) in Jordan in 2001?
Keep it short and to the point. 1.45e+06. What is the difference between the Aid flow (current US$) of Congo (Republic) in 1999 and the Aid flow (current US$) of Seychelles in 2001?
Your response must be concise. 3.16e+06. What is the difference between the Aid flow (current US$) of Egypt, Arab Rep. in 1999 and the Aid flow (current US$) of Jordan in 2001?
Your answer should be compact. 1.19e+07. What is the difference between the Aid flow (current US$) in Egypt, Arab Rep. in 1999 and the Aid flow (current US$) in Seychelles in 2001?
Keep it short and to the point. 1.36e+07. What is the difference between the Aid flow (current US$) in Jordan in 1999 and the Aid flow (current US$) in Seychelles in 2001?
Make the answer very short. 2.29e+06. What is the difference between the Aid flow (current US$) of Congo (Republic) in 1999 and the Aid flow (current US$) of Egypt, Arab Rep. in 2002?
Make the answer very short. -6.81e+06. What is the difference between the Aid flow (current US$) of Congo (Republic) in 1999 and the Aid flow (current US$) of Jordan in 2002?
Give a very brief answer. -4.90e+05. What is the difference between the Aid flow (current US$) in Congo (Republic) in 1999 and the Aid flow (current US$) in Seychelles in 2002?
Give a very brief answer. 3.11e+06. What is the difference between the Aid flow (current US$) of Egypt, Arab Rep. in 1999 and the Aid flow (current US$) of Jordan in 2002?
Give a very brief answer. 9.94e+06. What is the difference between the Aid flow (current US$) in Egypt, Arab Rep. in 1999 and the Aid flow (current US$) in Seychelles in 2002?
Your answer should be compact. 1.35e+07. What is the difference between the Aid flow (current US$) of Jordan in 1999 and the Aid flow (current US$) of Seychelles in 2002?
Provide a short and direct response. 2.24e+06. What is the difference between the Aid flow (current US$) of Congo (Republic) in 2000 and the Aid flow (current US$) of Egypt, Arab Rep. in 2001?
Your response must be concise. -8.91e+06. What is the difference between the Aid flow (current US$) in Congo (Republic) in 2000 and the Aid flow (current US$) in Jordan in 2001?
Offer a terse response. -1.06e+06. What is the difference between the Aid flow (current US$) in Congo (Republic) in 2000 and the Aid flow (current US$) in Seychelles in 2001?
Ensure brevity in your answer.  6.50e+05. What is the difference between the Aid flow (current US$) of Egypt, Arab Rep. in 2000 and the Aid flow (current US$) of Jordan in 2001?
Your answer should be very brief. 7.44e+06. What is the difference between the Aid flow (current US$) of Egypt, Arab Rep. in 2000 and the Aid flow (current US$) of Seychelles in 2001?
Keep it short and to the point. 9.15e+06. What is the difference between the Aid flow (current US$) of Jordan in 2000 and the Aid flow (current US$) of Seychelles in 2001?
Make the answer very short. 1.87e+06. What is the difference between the Aid flow (current US$) of Congo (Republic) in 2000 and the Aid flow (current US$) of Egypt, Arab Rep. in 2002?
Keep it short and to the point. -9.32e+06. What is the difference between the Aid flow (current US$) of Egypt, Arab Rep. in 2000 and the Aid flow (current US$) of Jordan in 2002?
Your answer should be compact. 5.50e+06. What is the difference between the Aid flow (current US$) in Egypt, Arab Rep. in 2000 and the Aid flow (current US$) in Seychelles in 2002?
Offer a terse response. 9.10e+06. What is the difference between the Aid flow (current US$) in Jordan in 2000 and the Aid flow (current US$) in Seychelles in 2002?
Ensure brevity in your answer.  1.82e+06. What is the difference between the Aid flow (current US$) of Congo (Republic) in 2001 and the Aid flow (current US$) of Egypt, Arab Rep. in 2002?
Make the answer very short. -9.65e+06. What is the difference between the Aid flow (current US$) in Congo (Republic) in 2001 and the Aid flow (current US$) in Jordan in 2002?
Provide a short and direct response. -3.33e+06. What is the difference between the Aid flow (current US$) of Congo (Republic) in 2001 and the Aid flow (current US$) of Seychelles in 2002?
Your answer should be compact. 2.70e+05. What is the difference between the Aid flow (current US$) of Egypt, Arab Rep. in 2001 and the Aid flow (current US$) of Jordan in 2002?
Your answer should be compact. 5.91e+06. What is the difference between the Aid flow (current US$) of Egypt, Arab Rep. in 2001 and the Aid flow (current US$) of Seychelles in 2002?
Keep it short and to the point. 9.51e+06. What is the difference between the Aid flow (current US$) in Jordan in 2001 and the Aid flow (current US$) in Seychelles in 2002?
Provide a succinct answer. 1.66e+06. What is the average Aid flow (current US$) in Congo (Republic) per year?
Keep it short and to the point. 2.34e+06. What is the average Aid flow (current US$) of Egypt, Arab Rep. per year?
Provide a short and direct response. 3.14e+07. What is the average Aid flow (current US$) of Jordan per year?
Offer a terse response. 3.55e+06. What is the average Aid flow (current US$) of Seychelles per year?
Keep it short and to the point. 1.28e+05. In the year 1995, what is the difference between the Aid flow (current US$) in Congo (Republic) and Aid flow (current US$) in Egypt, Arab Rep.?
Offer a terse response. -6.30e+07. In the year 1995, what is the difference between the Aid flow (current US$) in Congo (Republic) and Aid flow (current US$) in Jordan?
Your response must be concise. -7.70e+06. In the year 1995, what is the difference between the Aid flow (current US$) of Egypt, Arab Rep. and Aid flow (current US$) of Jordan?
Your answer should be compact. 5.53e+07. In the year 1995, what is the difference between the Aid flow (current US$) in Egypt, Arab Rep. and Aid flow (current US$) in Seychelles?
Ensure brevity in your answer.  6.29e+07. In the year 1995, what is the difference between the Aid flow (current US$) in Jordan and Aid flow (current US$) in Seychelles?
Provide a succinct answer. 7.61e+06. In the year 1996, what is the difference between the Aid flow (current US$) of Congo (Republic) and Aid flow (current US$) of Egypt, Arab Rep.?
Keep it short and to the point. -1.07e+08. In the year 1996, what is the difference between the Aid flow (current US$) of Congo (Republic) and Aid flow (current US$) of Jordan?
Provide a succinct answer. 7.90e+05. In the year 1996, what is the difference between the Aid flow (current US$) of Congo (Republic) and Aid flow (current US$) of Seychelles?
Your response must be concise. 6.36e+06. In the year 1996, what is the difference between the Aid flow (current US$) of Egypt, Arab Rep. and Aid flow (current US$) of Jordan?
Give a very brief answer. 1.08e+08. In the year 1996, what is the difference between the Aid flow (current US$) in Egypt, Arab Rep. and Aid flow (current US$) in Seychelles?
Keep it short and to the point. 1.14e+08. In the year 1996, what is the difference between the Aid flow (current US$) of Jordan and Aid flow (current US$) of Seychelles?
Keep it short and to the point. 5.57e+06. In the year 1997, what is the difference between the Aid flow (current US$) of Congo (Republic) and Aid flow (current US$) of Egypt, Arab Rep.?
Offer a terse response. -1.32e+07. In the year 1997, what is the difference between the Aid flow (current US$) in Congo (Republic) and Aid flow (current US$) in Jordan?
Provide a short and direct response. 1.30e+06. In the year 1997, what is the difference between the Aid flow (current US$) in Congo (Republic) and Aid flow (current US$) in Seychelles?
Your answer should be very brief. 3.80e+06. In the year 1997, what is the difference between the Aid flow (current US$) in Egypt, Arab Rep. and Aid flow (current US$) in Jordan?
Your answer should be very brief. 1.45e+07. In the year 1997, what is the difference between the Aid flow (current US$) in Egypt, Arab Rep. and Aid flow (current US$) in Seychelles?
Provide a short and direct response. 1.70e+07. In the year 1997, what is the difference between the Aid flow (current US$) in Jordan and Aid flow (current US$) in Seychelles?
Ensure brevity in your answer.  2.50e+06. In the year 1998, what is the difference between the Aid flow (current US$) in Congo (Republic) and Aid flow (current US$) in Egypt, Arab Rep.?
Provide a succinct answer. -1.14e+07. In the year 1998, what is the difference between the Aid flow (current US$) of Congo (Republic) and Aid flow (current US$) of Jordan?
Your answer should be very brief. 9.70e+05. In the year 1998, what is the difference between the Aid flow (current US$) in Congo (Republic) and Aid flow (current US$) in Seychelles?
Make the answer very short. 3.27e+06. In the year 1998, what is the difference between the Aid flow (current US$) of Egypt, Arab Rep. and Aid flow (current US$) of Jordan?
Give a very brief answer. 1.24e+07. In the year 1998, what is the difference between the Aid flow (current US$) of Egypt, Arab Rep. and Aid flow (current US$) of Seychelles?
Ensure brevity in your answer.  1.47e+07. In the year 1998, what is the difference between the Aid flow (current US$) of Jordan and Aid flow (current US$) of Seychelles?
Provide a short and direct response. 2.30e+06. In the year 1999, what is the difference between the Aid flow (current US$) in Congo (Republic) and Aid flow (current US$) in Egypt, Arab Rep.?
Offer a terse response. -1.04e+07. In the year 1999, what is the difference between the Aid flow (current US$) of Congo (Republic) and Aid flow (current US$) of Jordan?
Offer a terse response. 8.70e+05. In the year 1999, what is the difference between the Aid flow (current US$) in Congo (Republic) and Aid flow (current US$) in Seychelles?
Make the answer very short. 3.13e+06. In the year 1999, what is the difference between the Aid flow (current US$) of Egypt, Arab Rep. and Aid flow (current US$) of Jordan?
Your answer should be very brief. 1.13e+07. In the year 1999, what is the difference between the Aid flow (current US$) of Egypt, Arab Rep. and Aid flow (current US$) of Seychelles?
Offer a very short reply. 1.36e+07. In the year 1999, what is the difference between the Aid flow (current US$) in Jordan and Aid flow (current US$) in Seychelles?
Your response must be concise. 2.26e+06. In the year 2000, what is the difference between the Aid flow (current US$) of Congo (Republic) and Aid flow (current US$) of Egypt, Arab Rep.?
Offer a very short reply. -8.50e+06. In the year 2000, what is the difference between the Aid flow (current US$) of Congo (Republic) and Aid flow (current US$) of Jordan?
Provide a succinct answer. -1.22e+06. In the year 2000, what is the difference between the Aid flow (current US$) in Congo (Republic) and Aid flow (current US$) in Seychelles?
Keep it short and to the point. 6.20e+05. In the year 2000, what is the difference between the Aid flow (current US$) in Egypt, Arab Rep. and Aid flow (current US$) in Jordan?
Your response must be concise. 7.28e+06. In the year 2000, what is the difference between the Aid flow (current US$) of Egypt, Arab Rep. and Aid flow (current US$) of Seychelles?
Keep it short and to the point. 9.12e+06. In the year 2000, what is the difference between the Aid flow (current US$) in Jordan and Aid flow (current US$) in Seychelles?
Your answer should be compact. 1.84e+06. In the year 2001, what is the difference between the Aid flow (current US$) of Congo (Republic) and Aid flow (current US$) of Egypt, Arab Rep.?
Offer a terse response. -9.24e+06. In the year 2001, what is the difference between the Aid flow (current US$) of Congo (Republic) and Aid flow (current US$) of Jordan?
Make the answer very short. -1.39e+06. In the year 2001, what is the difference between the Aid flow (current US$) of Egypt, Arab Rep. and Aid flow (current US$) of Jordan?
Give a very brief answer. 7.85e+06. In the year 2001, what is the difference between the Aid flow (current US$) in Egypt, Arab Rep. and Aid flow (current US$) in Seychelles?
Your response must be concise. 9.56e+06. In the year 2001, what is the difference between the Aid flow (current US$) in Jordan and Aid flow (current US$) in Seychelles?
Your response must be concise. 1.71e+06. In the year 2002, what is the difference between the Aid flow (current US$) in Congo (Republic) and Aid flow (current US$) in Egypt, Arab Rep.?
Offer a very short reply. -9.59e+06. In the year 2002, what is the difference between the Aid flow (current US$) in Congo (Republic) and Aid flow (current US$) in Jordan?
Keep it short and to the point. -3.27e+06. In the year 2002, what is the difference between the Aid flow (current US$) of Egypt, Arab Rep. and Aid flow (current US$) of Jordan?
Provide a short and direct response. 6.32e+06. In the year 2002, what is the difference between the Aid flow (current US$) of Egypt, Arab Rep. and Aid flow (current US$) of Seychelles?
Provide a succinct answer. 9.92e+06. In the year 2002, what is the difference between the Aid flow (current US$) in Jordan and Aid flow (current US$) in Seychelles?
Your response must be concise. 3.60e+06. What is the ratio of the Aid flow (current US$) in Congo (Republic) in 1995 to that in 1996?
Offer a very short reply. 0.03. What is the ratio of the Aid flow (current US$) in Egypt, Arab Rep. in 1995 to that in 1996?
Make the answer very short. 0.55. What is the ratio of the Aid flow (current US$) in Jordan in 1995 to that in 1996?
Your response must be concise. 1.31. What is the ratio of the Aid flow (current US$) of Seychelles in 1995 to that in 1996?
Your answer should be very brief. 0.62. What is the ratio of the Aid flow (current US$) in Congo (Republic) in 1995 to that in 1997?
Offer a terse response. 0.06. What is the ratio of the Aid flow (current US$) of Egypt, Arab Rep. in 1995 to that in 1997?
Your answer should be compact. 3.71. What is the ratio of the Aid flow (current US$) in Jordan in 1995 to that in 1997?
Ensure brevity in your answer.  3.14. What is the ratio of the Aid flow (current US$) in Congo (Republic) in 1995 to that in 1998?
Provide a short and direct response. 0.06. What is the ratio of the Aid flow (current US$) in Egypt, Arab Rep. in 1995 to that in 1998?
Your answer should be compact. 4.29. What is the ratio of the Aid flow (current US$) in Jordan in 1995 to that in 1998?
Provide a short and direct response. 3.39. What is the ratio of the Aid flow (current US$) of Congo (Republic) in 1995 to that in 1999?
Give a very brief answer. 0.07. What is the ratio of the Aid flow (current US$) of Egypt, Arab Rep. in 1995 to that in 1999?
Offer a terse response. 4.64. What is the ratio of the Aid flow (current US$) of Jordan in 1995 to that in 1999?
Provide a short and direct response. 3.42. What is the ratio of the Aid flow (current US$) of Congo (Republic) in 1995 to that in 2000?
Your answer should be compact. 0.31. What is the ratio of the Aid flow (current US$) of Egypt, Arab Rep. in 1995 to that in 2000?
Offer a very short reply. 6.89. What is the ratio of the Aid flow (current US$) in Jordan in 1995 to that in 2000?
Provide a succinct answer. 4.19. What is the ratio of the Aid flow (current US$) in Seychelles in 1995 to that in 2000?
Keep it short and to the point. 6. What is the ratio of the Aid flow (current US$) in Congo (Republic) in 1995 to that in 2001?
Keep it short and to the point. 0.62. What is the ratio of the Aid flow (current US$) in Egypt, Arab Rep. in 1995 to that in 2001?
Keep it short and to the point. 6.6. What is the ratio of the Aid flow (current US$) in Jordan in 1995 to that in 2001?
Your answer should be very brief. 4.57. What is the ratio of the Aid flow (current US$) in Seychelles in 1995 to that in 2001?
Provide a short and direct response. 15. What is the ratio of the Aid flow (current US$) in Congo (Republic) in 1995 to that in 2002?
Provide a succinct answer. 0.53. What is the ratio of the Aid flow (current US$) in Egypt, Arab Rep. in 1995 to that in 2002?
Provide a succinct answer. 6.33. What is the ratio of the Aid flow (current US$) of Jordan in 1995 to that in 2002?
Your answer should be compact. 2.16. What is the ratio of the Aid flow (current US$) of Seychelles in 1995 to that in 2002?
Your response must be concise. 4.29. What is the ratio of the Aid flow (current US$) of Congo (Republic) in 1996 to that in 1997?
Provide a short and direct response. 1.79. What is the ratio of the Aid flow (current US$) in Egypt, Arab Rep. in 1996 to that in 1997?
Give a very brief answer. 6.69. What is the ratio of the Aid flow (current US$) of Jordan in 1996 to that in 1997?
Your answer should be compact. 2.4. What is the ratio of the Aid flow (current US$) in Seychelles in 1996 to that in 1997?
Your response must be concise. 24. What is the ratio of the Aid flow (current US$) in Congo (Republic) in 1996 to that in 1998?
Your answer should be compact. 2.07. What is the ratio of the Aid flow (current US$) in Egypt, Arab Rep. in 1996 to that in 1998?
Give a very brief answer. 7.74. What is the ratio of the Aid flow (current US$) in Jordan in 1996 to that in 1998?
Ensure brevity in your answer.  2.6. What is the ratio of the Aid flow (current US$) of Congo (Republic) in 1996 to that in 1999?
Make the answer very short. 2.15. What is the ratio of the Aid flow (current US$) of Egypt, Arab Rep. in 1996 to that in 1999?
Provide a succinct answer. 8.38. What is the ratio of the Aid flow (current US$) of Jordan in 1996 to that in 1999?
Your answer should be compact. 2.62. What is the ratio of the Aid flow (current US$) of Congo (Republic) in 1996 to that in 2000?
Ensure brevity in your answer.  10.21. What is the ratio of the Aid flow (current US$) of Egypt, Arab Rep. in 1996 to that in 2000?
Offer a very short reply. 12.44. What is the ratio of the Aid flow (current US$) of Jordan in 1996 to that in 2000?
Make the answer very short. 3.2. What is the ratio of the Aid flow (current US$) of Seychelles in 1996 to that in 2000?
Provide a succinct answer. 9.6. What is the ratio of the Aid flow (current US$) in Congo (Republic) in 1996 to that in 2001?
Your answer should be compact. 20.12. What is the ratio of the Aid flow (current US$) of Egypt, Arab Rep. in 1996 to that in 2001?
Provide a succinct answer. 11.9. What is the ratio of the Aid flow (current US$) in Jordan in 1996 to that in 2001?
Keep it short and to the point. 3.5. What is the ratio of the Aid flow (current US$) in Egypt, Arab Rep. in 1996 to that in 2002?
Provide a short and direct response. 11.41. What is the ratio of the Aid flow (current US$) of Jordan in 1996 to that in 2002?
Your answer should be very brief. 1.65. What is the ratio of the Aid flow (current US$) of Seychelles in 1996 to that in 2002?
Your answer should be compact. 6.86. What is the ratio of the Aid flow (current US$) in Congo (Republic) in 1997 to that in 1998?
Offer a very short reply. 1.16. What is the ratio of the Aid flow (current US$) in Egypt, Arab Rep. in 1997 to that in 1998?
Keep it short and to the point. 1.16. What is the ratio of the Aid flow (current US$) in Jordan in 1997 to that in 1998?
Keep it short and to the point. 1.08. What is the ratio of the Aid flow (current US$) of Seychelles in 1997 to that in 1998?
Offer a terse response. 0.67. What is the ratio of the Aid flow (current US$) of Congo (Republic) in 1997 to that in 1999?
Your response must be concise. 1.2. What is the ratio of the Aid flow (current US$) of Egypt, Arab Rep. in 1997 to that in 1999?
Your response must be concise. 1.25. What is the ratio of the Aid flow (current US$) in Seychelles in 1997 to that in 1999?
Your response must be concise. 0.4. What is the ratio of the Aid flow (current US$) of Congo (Republic) in 1997 to that in 2000?
Make the answer very short. 5.7. What is the ratio of the Aid flow (current US$) in Egypt, Arab Rep. in 1997 to that in 2000?
Offer a terse response. 1.86. What is the ratio of the Aid flow (current US$) of Jordan in 1997 to that in 2000?
Your answer should be compact. 1.33. What is the ratio of the Aid flow (current US$) of Congo (Republic) in 1997 to that in 2001?
Ensure brevity in your answer.  11.24. What is the ratio of the Aid flow (current US$) of Egypt, Arab Rep. in 1997 to that in 2001?
Provide a succinct answer. 1.78. What is the ratio of the Aid flow (current US$) of Jordan in 1997 to that in 2001?
Provide a succinct answer. 1.46. What is the ratio of the Aid flow (current US$) of Congo (Republic) in 1997 to that in 2002?
Give a very brief answer. 9.55. What is the ratio of the Aid flow (current US$) in Egypt, Arab Rep. in 1997 to that in 2002?
Keep it short and to the point. 1.71. What is the ratio of the Aid flow (current US$) of Jordan in 1997 to that in 2002?
Offer a very short reply. 0.69. What is the ratio of the Aid flow (current US$) of Seychelles in 1997 to that in 2002?
Ensure brevity in your answer.  0.29. What is the ratio of the Aid flow (current US$) of Congo (Republic) in 1998 to that in 1999?
Offer a terse response. 1.04. What is the ratio of the Aid flow (current US$) in Egypt, Arab Rep. in 1998 to that in 1999?
Keep it short and to the point. 1.08. What is the ratio of the Aid flow (current US$) of Jordan in 1998 to that in 1999?
Offer a very short reply. 1.01. What is the ratio of the Aid flow (current US$) of Congo (Republic) in 1998 to that in 2000?
Give a very brief answer. 4.93. What is the ratio of the Aid flow (current US$) of Egypt, Arab Rep. in 1998 to that in 2000?
Ensure brevity in your answer.  1.61. What is the ratio of the Aid flow (current US$) of Jordan in 1998 to that in 2000?
Make the answer very short. 1.23. What is the ratio of the Aid flow (current US$) of Seychelles in 1998 to that in 2000?
Provide a succinct answer. 0.6. What is the ratio of the Aid flow (current US$) in Congo (Republic) in 1998 to that in 2001?
Offer a terse response. 9.71. What is the ratio of the Aid flow (current US$) of Egypt, Arab Rep. in 1998 to that in 2001?
Provide a short and direct response. 1.54. What is the ratio of the Aid flow (current US$) of Jordan in 1998 to that in 2001?
Provide a short and direct response. 1.35. What is the ratio of the Aid flow (current US$) in Congo (Republic) in 1998 to that in 2002?
Make the answer very short. 8.25. What is the ratio of the Aid flow (current US$) in Egypt, Arab Rep. in 1998 to that in 2002?
Your answer should be very brief. 1.47. What is the ratio of the Aid flow (current US$) of Jordan in 1998 to that in 2002?
Your response must be concise. 0.63. What is the ratio of the Aid flow (current US$) in Seychelles in 1998 to that in 2002?
Keep it short and to the point. 0.43. What is the ratio of the Aid flow (current US$) in Congo (Republic) in 1999 to that in 2000?
Your answer should be compact. 4.75. What is the ratio of the Aid flow (current US$) in Egypt, Arab Rep. in 1999 to that in 2000?
Provide a short and direct response. 1.48. What is the ratio of the Aid flow (current US$) of Jordan in 1999 to that in 2000?
Give a very brief answer. 1.22. What is the ratio of the Aid flow (current US$) of Seychelles in 1999 to that in 2000?
Offer a terse response. 1. What is the ratio of the Aid flow (current US$) of Congo (Republic) in 1999 to that in 2001?
Offer a very short reply. 9.35. What is the ratio of the Aid flow (current US$) in Egypt, Arab Rep. in 1999 to that in 2001?
Make the answer very short. 1.42. What is the ratio of the Aid flow (current US$) in Jordan in 1999 to that in 2001?
Your answer should be very brief. 1.34. What is the ratio of the Aid flow (current US$) of Seychelles in 1999 to that in 2001?
Your answer should be compact. 2.5. What is the ratio of the Aid flow (current US$) in Congo (Republic) in 1999 to that in 2002?
Provide a short and direct response. 7.95. What is the ratio of the Aid flow (current US$) in Egypt, Arab Rep. in 1999 to that in 2002?
Your response must be concise. 1.36. What is the ratio of the Aid flow (current US$) in Jordan in 1999 to that in 2002?
Make the answer very short. 0.63. What is the ratio of the Aid flow (current US$) of Seychelles in 1999 to that in 2002?
Your response must be concise. 0.71. What is the ratio of the Aid flow (current US$) of Congo (Republic) in 2000 to that in 2001?
Your answer should be compact. 1.97. What is the ratio of the Aid flow (current US$) of Egypt, Arab Rep. in 2000 to that in 2001?
Offer a terse response. 0.96. What is the ratio of the Aid flow (current US$) of Jordan in 2000 to that in 2001?
Provide a short and direct response. 1.09. What is the ratio of the Aid flow (current US$) of Congo (Republic) in 2000 to that in 2002?
Provide a succinct answer. 1.68. What is the ratio of the Aid flow (current US$) of Egypt, Arab Rep. in 2000 to that in 2002?
Keep it short and to the point. 0.92. What is the ratio of the Aid flow (current US$) of Jordan in 2000 to that in 2002?
Provide a short and direct response. 0.52. What is the ratio of the Aid flow (current US$) of Seychelles in 2000 to that in 2002?
Your answer should be compact. 0.71. What is the ratio of the Aid flow (current US$) of Congo (Republic) in 2001 to that in 2002?
Provide a short and direct response. 0.85. What is the ratio of the Aid flow (current US$) in Egypt, Arab Rep. in 2001 to that in 2002?
Give a very brief answer. 0.96. What is the ratio of the Aid flow (current US$) of Jordan in 2001 to that in 2002?
Ensure brevity in your answer.  0.47. What is the ratio of the Aid flow (current US$) of Seychelles in 2001 to that in 2002?
Offer a very short reply. 0.29. What is the difference between the highest and the second highest Aid flow (current US$) of Congo (Republic)?
Offer a terse response. 3.02e+06. What is the difference between the highest and the second highest Aid flow (current US$) of Egypt, Arab Rep.?
Ensure brevity in your answer.  5.08e+07. What is the difference between the highest and the second highest Aid flow (current US$) in Jordan?
Ensure brevity in your answer.  1.86e+06. What is the difference between the highest and the second highest Aid flow (current US$) of Seychelles?
Give a very brief answer. 1.80e+05. What is the difference between the highest and the lowest Aid flow (current US$) in Congo (Republic)?
Your response must be concise. 6.63e+06. What is the difference between the highest and the lowest Aid flow (current US$) in Egypt, Arab Rep.?
Keep it short and to the point. 1.05e+08. What is the difference between the highest and the lowest Aid flow (current US$) of Jordan?
Keep it short and to the point. 6.18e+06. What is the difference between the highest and the lowest Aid flow (current US$) in Seychelles?
Offer a very short reply. 4.60e+05. 